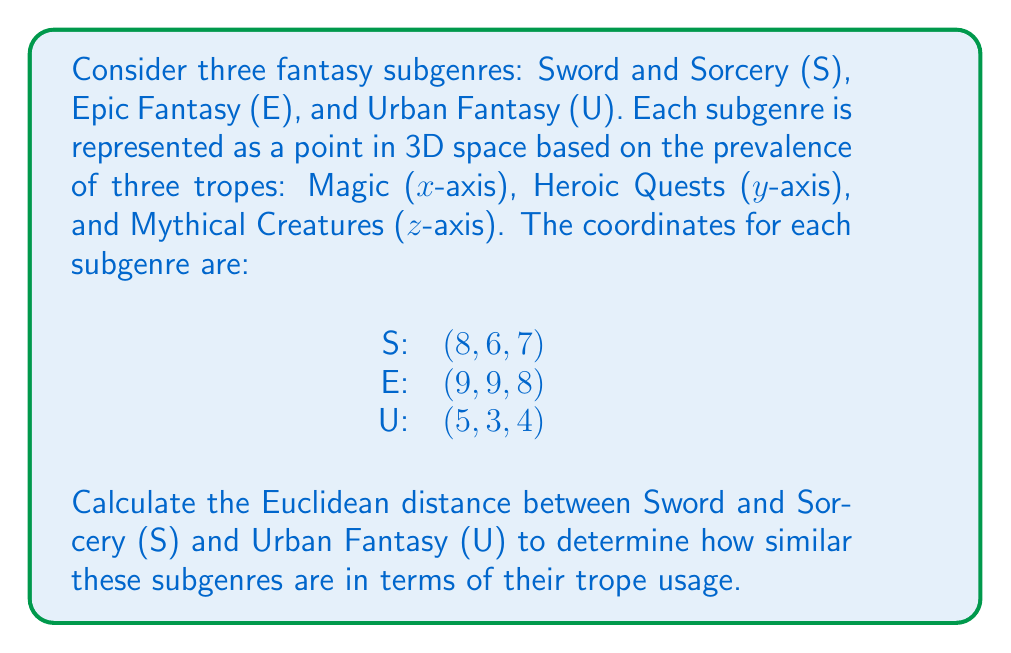Provide a solution to this math problem. To solve this problem, we'll use the Euclidean distance formula in 3D space. The formula is:

$$ d = \sqrt{(x_2 - x_1)^2 + (y_2 - y_1)^2 + (z_2 - z_1)^2} $$

Where $(x_1, y_1, z_1)$ are the coordinates of the first point and $(x_2, y_2, z_2)$ are the coordinates of the second point.

Let's plug in the values for Sword and Sorcery (S) and Urban Fantasy (U):

S: $(x_1, y_1, z_1) = (8, 6, 7)$
U: $(x_2, y_2, z_2) = (5, 3, 4)$

Now, let's calculate each part of the formula:

1. $(x_2 - x_1)^2 = (5 - 8)^2 = (-3)^2 = 9$
2. $(y_2 - y_1)^2 = (3 - 6)^2 = (-3)^2 = 9$
3. $(z_2 - z_1)^2 = (4 - 7)^2 = (-3)^2 = 9$

Adding these up:

$$ 9 + 9 + 9 = 27 $$

Now, we take the square root:

$$ d = \sqrt{27} $$

Simplifying:

$$ d = 3\sqrt{3} $$

This is the Euclidean distance between Sword and Sorcery (S) and Urban Fantasy (U) in our 3D trope space.
Answer: $3\sqrt{3}$ 